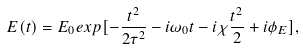Convert formula to latex. <formula><loc_0><loc_0><loc_500><loc_500>E ( t ) = E _ { 0 } e x p [ - \frac { t ^ { 2 } } { 2 \tau ^ { 2 } } - i \omega _ { 0 } t - i \chi \frac { t ^ { 2 } } { 2 } + i \phi _ { E } ] ,</formula> 